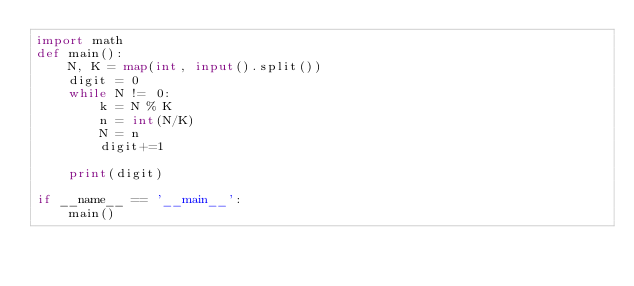Convert code to text. <code><loc_0><loc_0><loc_500><loc_500><_Python_>import math
def main():
    N, K = map(int, input().split())
    digit = 0
    while N != 0:
        k = N % K
        n = int(N/K)
        N = n
        digit+=1

    print(digit)

if __name__ == '__main__':
    main()</code> 